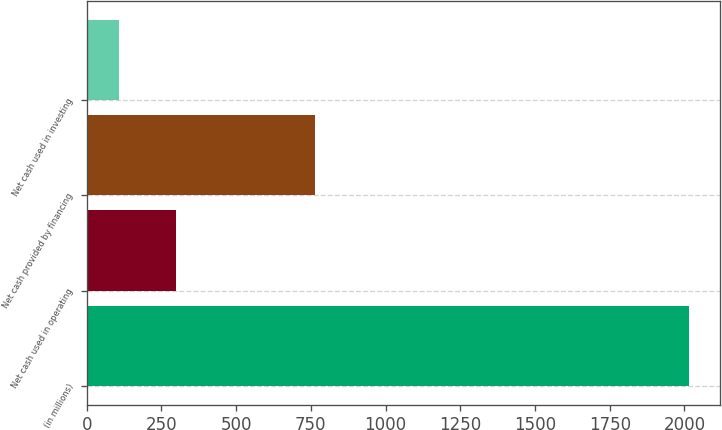Convert chart. <chart><loc_0><loc_0><loc_500><loc_500><bar_chart><fcel>(in millions)<fcel>Net cash used in operating<fcel>Net cash provided by financing<fcel>Net cash used in investing<nl><fcel>2017<fcel>298<fcel>764<fcel>107<nl></chart> 